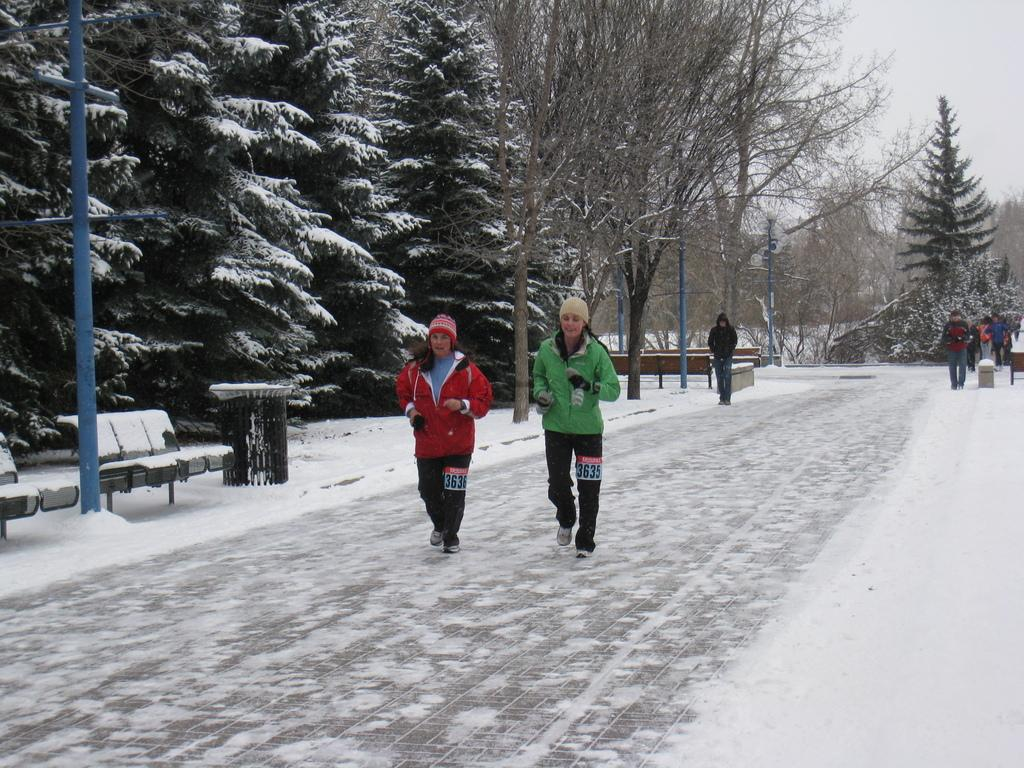What are the people in the image doing? The people in the image are walking. How can you describe the clothing of the people in the image? The people are wearing different color dresses. What type of outdoor furniture is present in the image? There are benches in the image. What type of vegetation is visible in the image? There are trees in the image. What type of structures are present in the image? There are poles in the image. What is the weather like in the image? There is snow visible in the image, and the sky is white in color. Where is the cemetery located in the image? There is no cemetery present in the image. How do the people in the image maintain their grip on the snow? The image does not show the people's grip on the snow, as it is focused on their walking and clothing. 